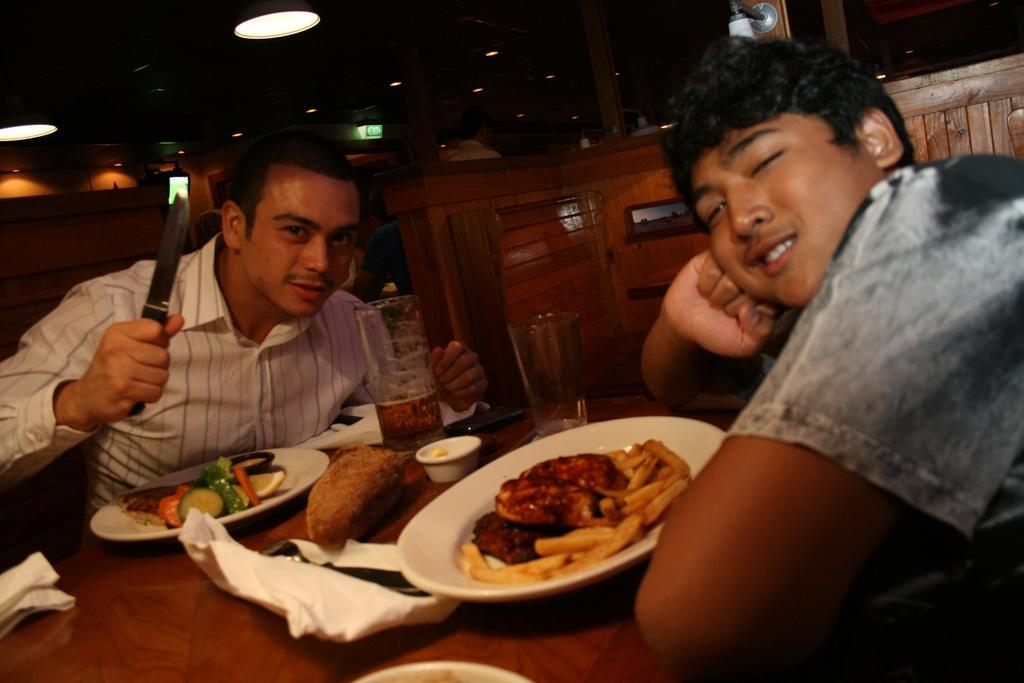What type of furniture is present in the image? There are chairs and a table in the image. How many people are sitting in the image? Two persons are sitting in the image. What is on the table in the image? There are plates and food items on the table. What can be seen at the top of the image? There are lights visible at the top of the image. What is the mass of the cent in the image? There is no cent present in the image, so it is not possible to determine its mass. 